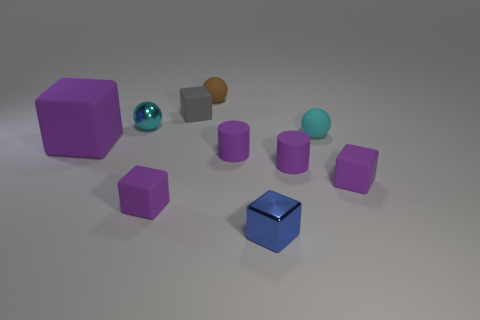What color is the small rubber cube to the right of the rubber ball to the right of the brown rubber ball? purple 